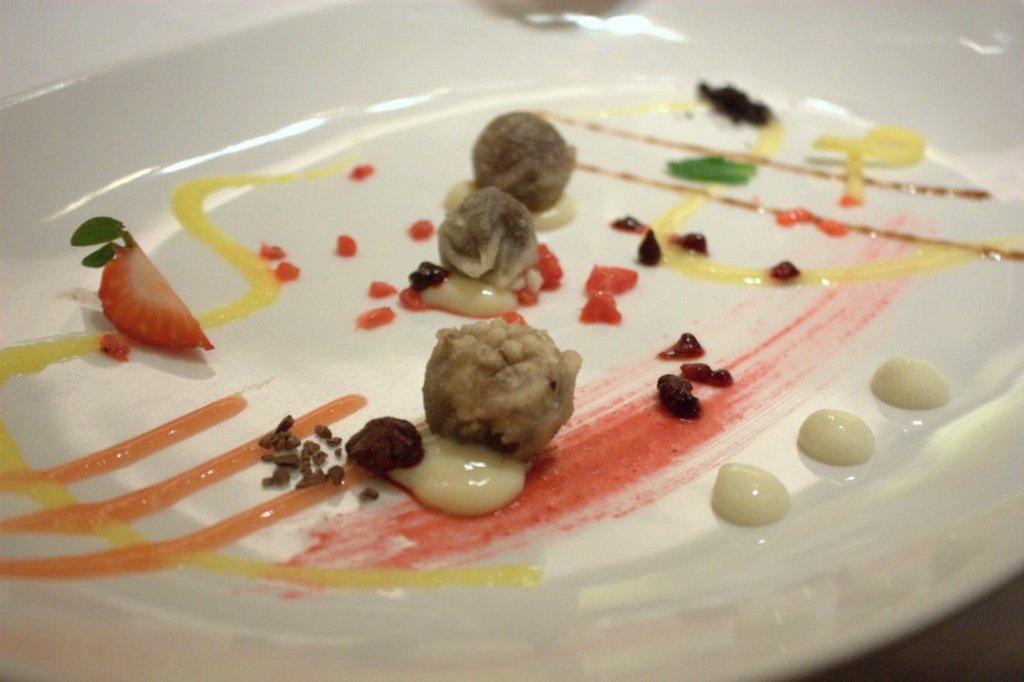Please provide a concise description of this image. This image consist of food which is on the plate which is white in colour. 